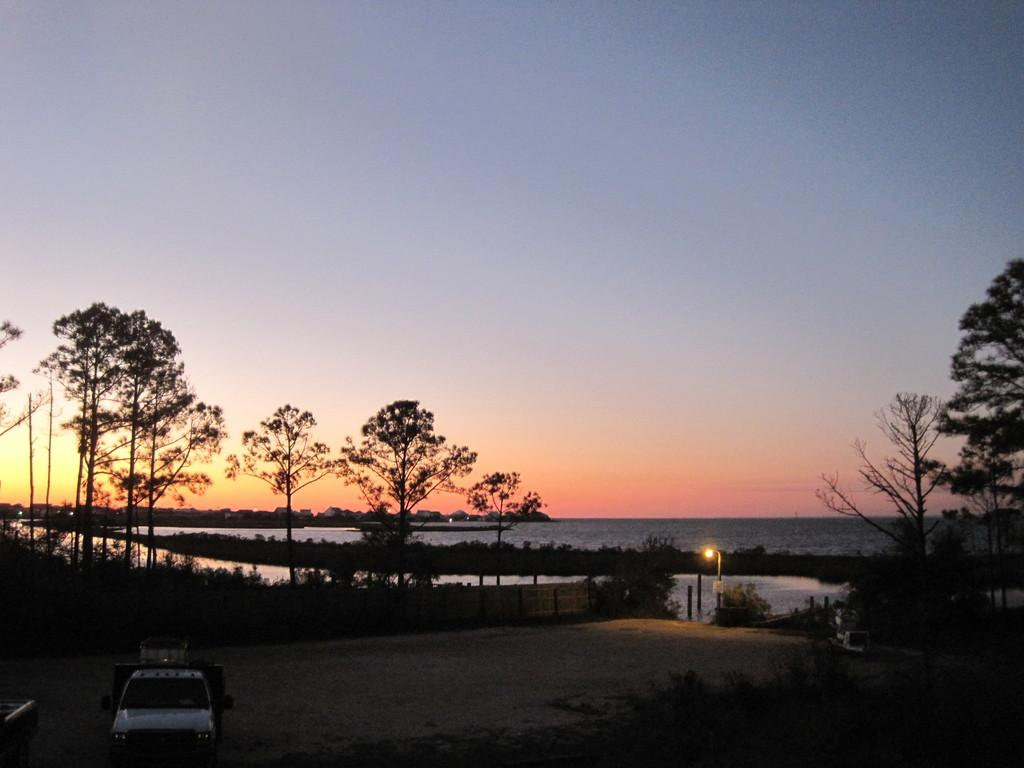What type of natural elements can be seen in the image? There are trees and plants visible in the image. What is the water feature in the image? The water is visible in the image. What type of man-made structure is present in the image? There is a vehicle in the image. What can be seen in the background of the image? There are buildings in the background of the image. What is the color of the sky in the image? The sky is blue in the image. How many men are playing cards in the room in the image? There is no room or men playing cards present in the image. 